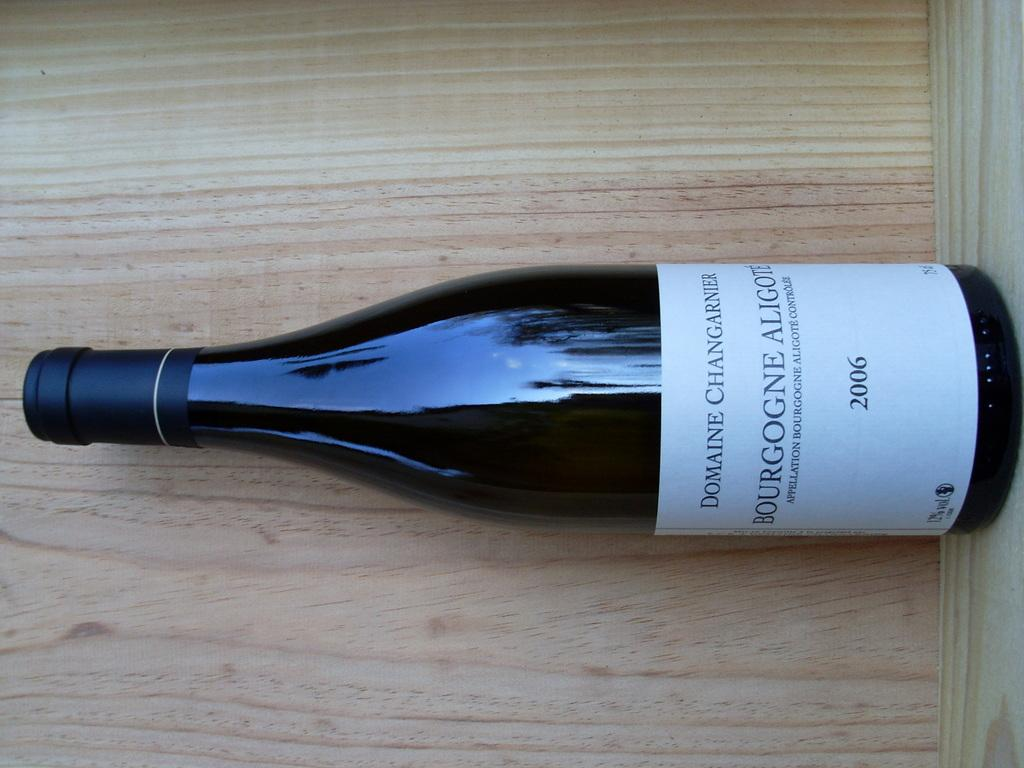<image>
Share a concise interpretation of the image provided. the year 2006 that is on a bottle 